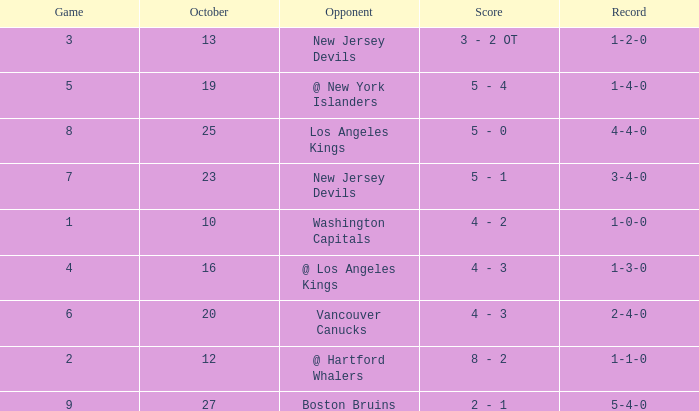Which game has the highest score in October with 9? 27.0. 